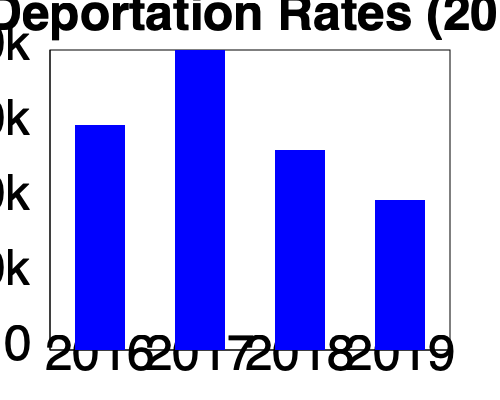Based on the bar graph showing deportation rates from 2016 to 2019, what was the overall trend in deportations during this period, and which year saw the highest number of deportations? To answer this question, we need to analyze the bar graph step-by-step:

1. Examine the y-axis: It represents the number of deportations, ranging from 0 to 400k (400,000).

2. Analyze each year's deportation rate:
   - 2016: The bar reaches approximately 300k
   - 2017: The bar reaches the 400k mark
   - 2018: The bar is slightly lower than 2016, around 250k
   - 2019: The bar is the lowest, reaching about 200k

3. Identify the overall trend:
   The deportation rate increased sharply from 2016 to 2017, then decreased significantly in 2018 and 2019. This indicates an overall downward trend after 2017.

4. Determine the year with the highest deportations:
   2017 clearly has the tallest bar, reaching the 400k mark, indicating it had the highest number of deportations.
Answer: Downward trend after 2017; highest in 2017 